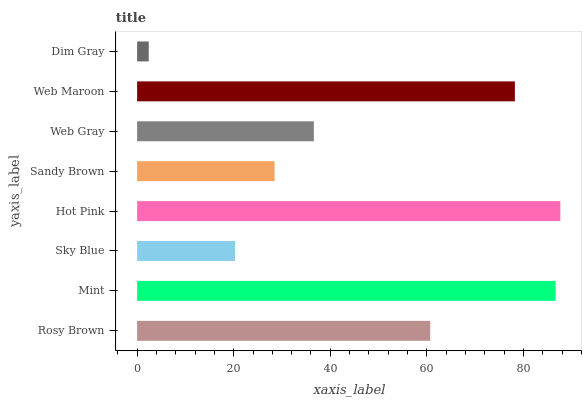Is Dim Gray the minimum?
Answer yes or no. Yes. Is Hot Pink the maximum?
Answer yes or no. Yes. Is Mint the minimum?
Answer yes or no. No. Is Mint the maximum?
Answer yes or no. No. Is Mint greater than Rosy Brown?
Answer yes or no. Yes. Is Rosy Brown less than Mint?
Answer yes or no. Yes. Is Rosy Brown greater than Mint?
Answer yes or no. No. Is Mint less than Rosy Brown?
Answer yes or no. No. Is Rosy Brown the high median?
Answer yes or no. Yes. Is Web Gray the low median?
Answer yes or no. Yes. Is Hot Pink the high median?
Answer yes or no. No. Is Hot Pink the low median?
Answer yes or no. No. 